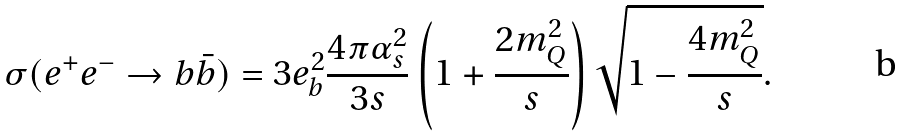Convert formula to latex. <formula><loc_0><loc_0><loc_500><loc_500>\sigma ( e ^ { + } e ^ { - } \to b \bar { b } ) = 3 e _ { b } ^ { 2 } \frac { 4 \pi \alpha _ { s } ^ { 2 } } { 3 s } \left ( 1 + \frac { 2 m _ { Q } ^ { 2 } } { s } \right ) \sqrt { 1 - \frac { 4 m _ { Q } ^ { 2 } } { s } } .</formula> 